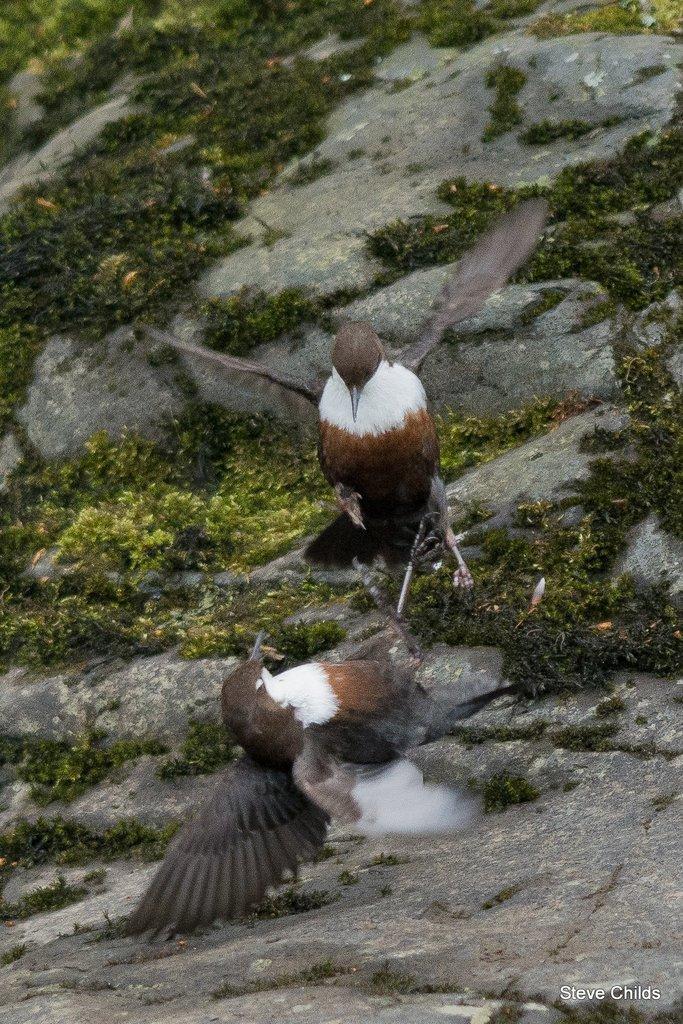In one or two sentences, can you explain what this image depicts? In this picture we can see the mountains and the thicket. We can see the birds. In the bottom right corner of the picture we can see the watermark. 